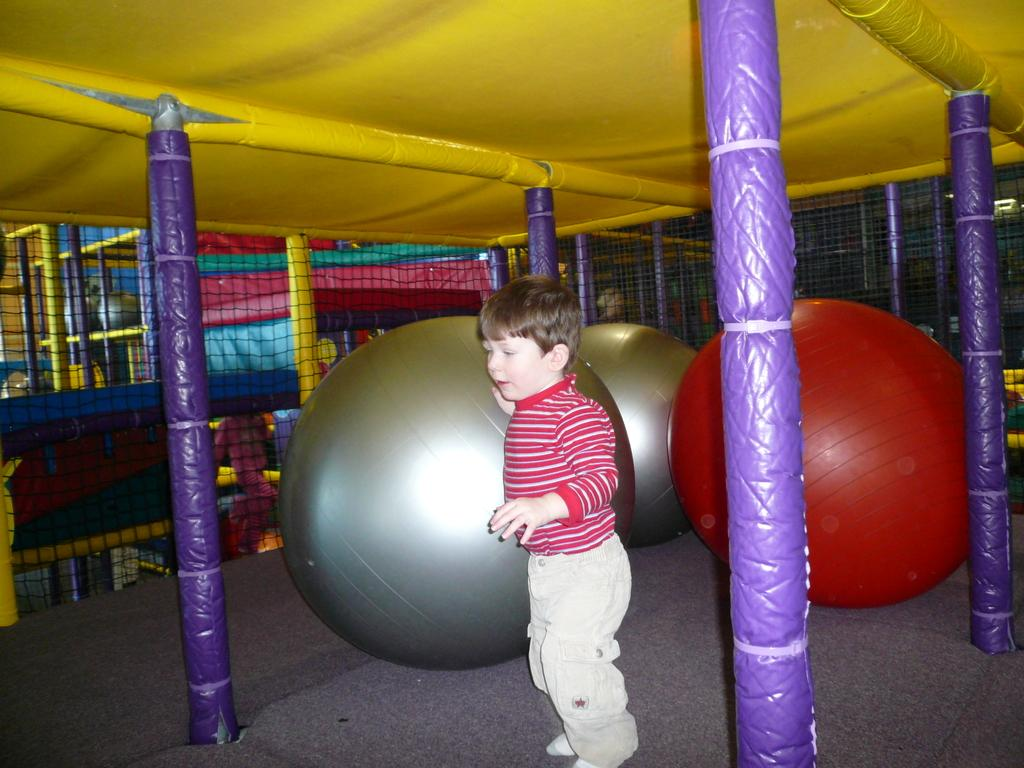What architectural features can be seen in the image? There are pillars in the image. Who or what is located at the bottom of the image? There is a kid at the bottom of the image. What is the kid wearing? The kid is wearing clothes. What is the kid standing in front of? The kid is standing in front of balls. What type of barrier is present in the middle of the image? There are mesh grills in the middle of the image. What type of jeans is the kid wearing in the image? The provided facts do not mention the type of jeans the kid is wearing, nor do they mention any jeans at all. --- Facts: 1. There is a person holding a book in the image. 2. The book has a blue cover. 3. The person is sitting on a chair. 4. There is a table next to the chair. 5. The table has a lamp on it. Absurd Topics: bicycle, ocean, bird Conversation: What is the person in the image holding? The person is holding a book in the image. What color is the book's cover? The book has a blue cover. Where is the person sitting? The person is sitting on a chair. What is located next to the chair? There is a table next to the chair. What object is on the table? The table has a lamp on it. Reasoning: Let's think step by step in order to produce the conversation. We start by identifying the main subject in the image, which is the person holding a book. Then, we expand the conversation to include details about the book, such as its color, and the person's position, such as where they are sitting. Finally, we mention the table and lamp as additional objects in the image. Absurd Question/Answer: Can you see any bicycles in the image? No, there are no bicycles present in the image. Is the person near the ocean in the image? No, there is no indication of an ocean or any body of water in the image. 